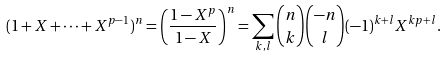<formula> <loc_0><loc_0><loc_500><loc_500>( 1 + X + \cdots + X ^ { p - 1 } ) ^ { n } = \left ( \frac { 1 - X ^ { p } } { 1 - X } \right ) ^ { n } = \sum _ { k , l } \binom { n } { k } \binom { - n } l ( - 1 ) ^ { k + l } X ^ { k p + l } .</formula> 